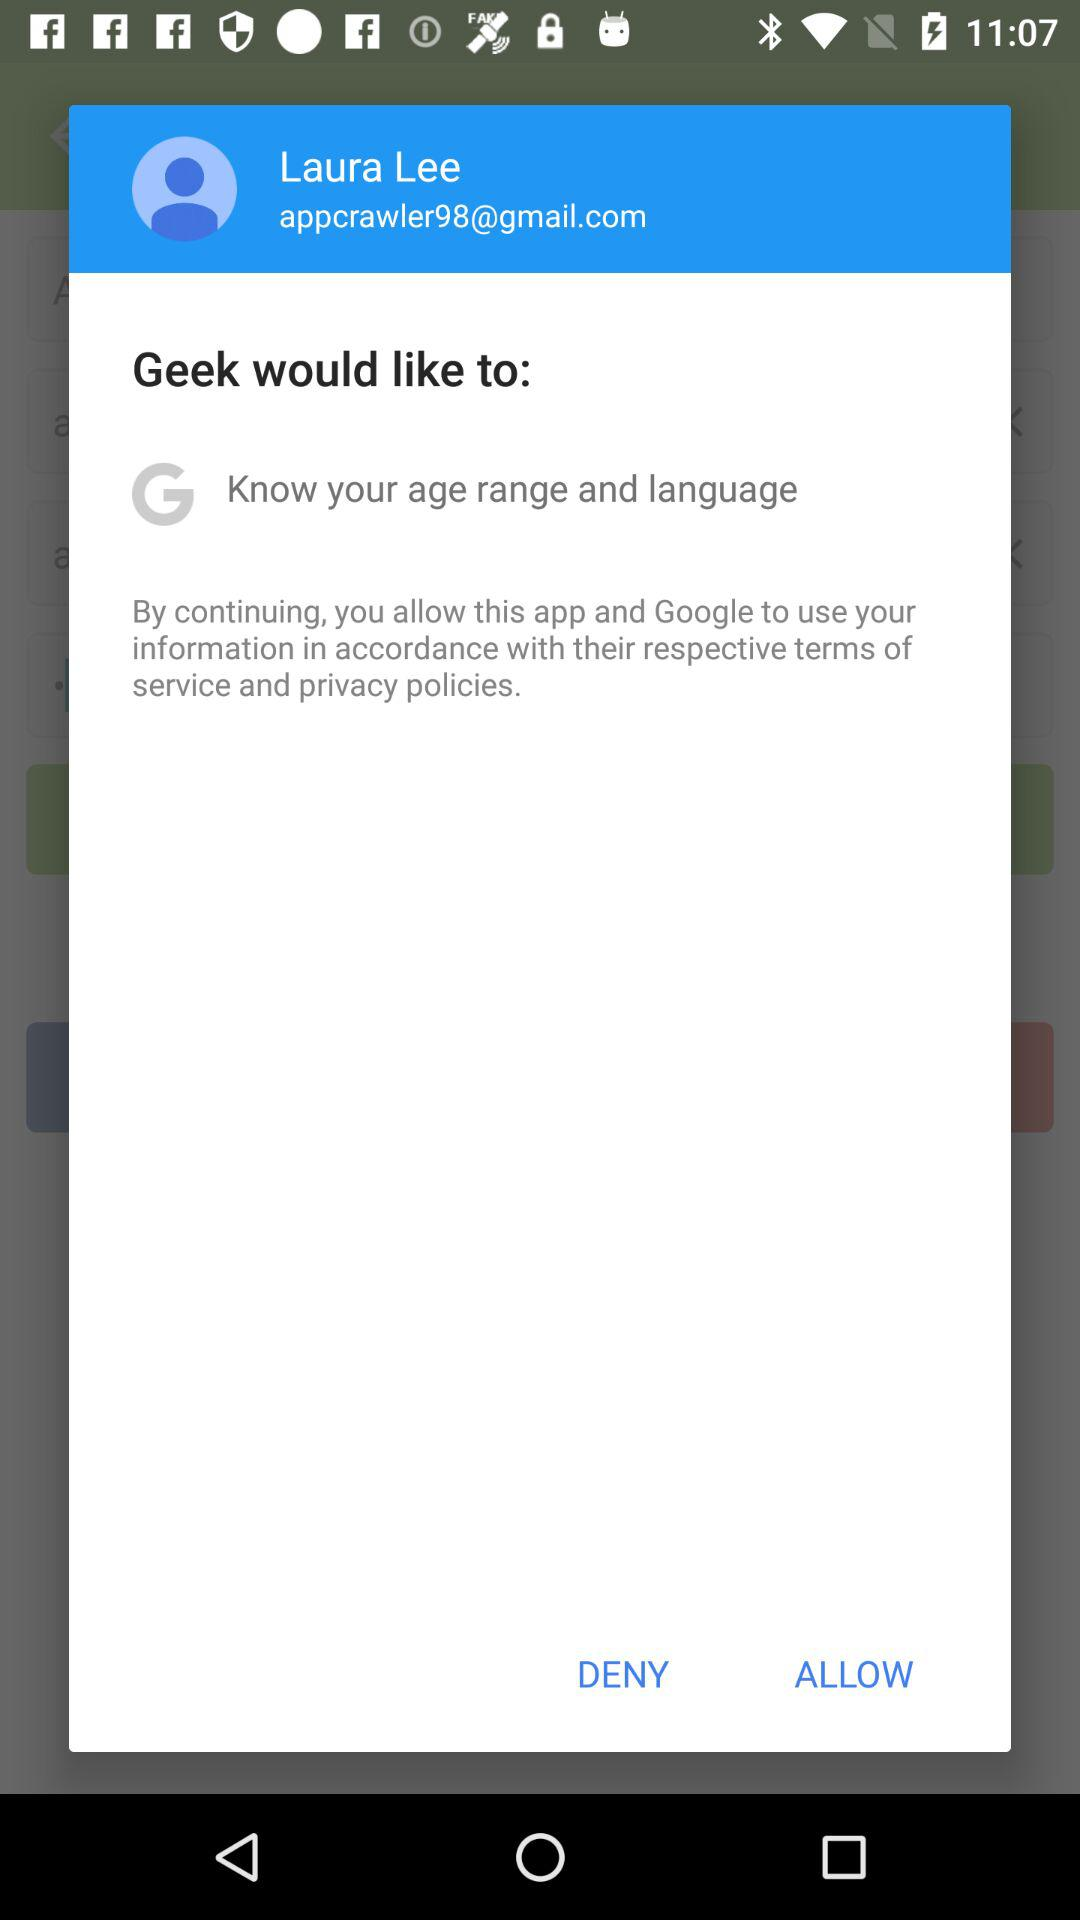What application is asking for permission? The application asking for permission is "Geek". 